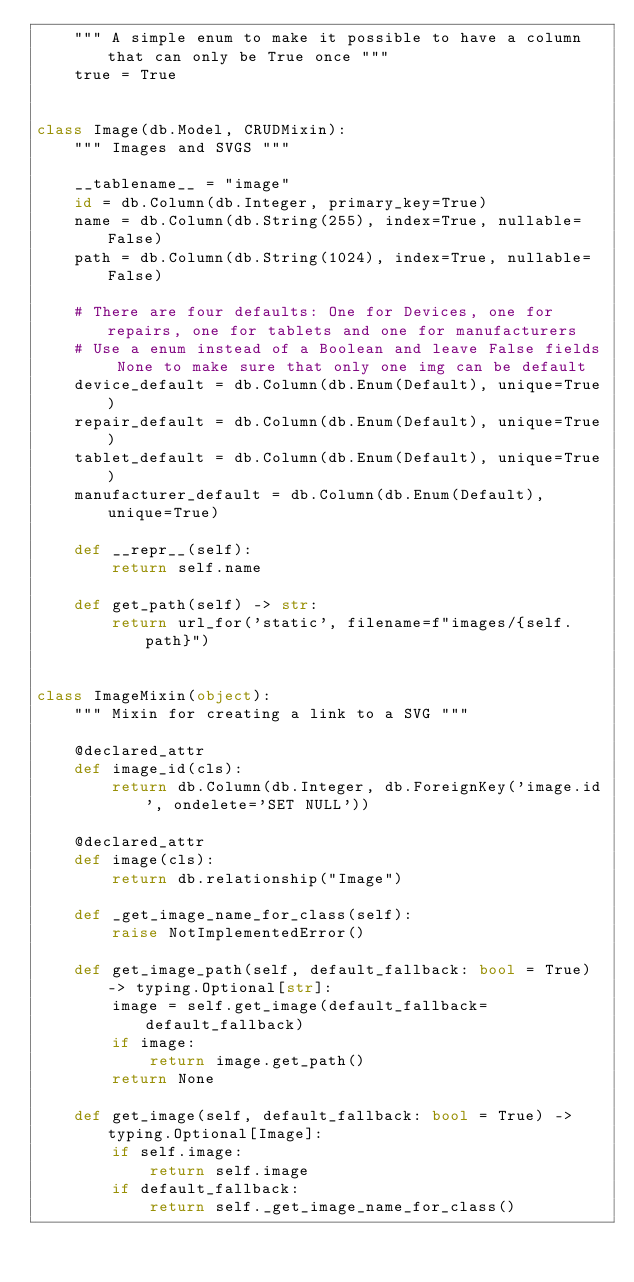Convert code to text. <code><loc_0><loc_0><loc_500><loc_500><_Python_>    """ A simple enum to make it possible to have a column that can only be True once """
    true = True


class Image(db.Model, CRUDMixin):
    """ Images and SVGS """

    __tablename__ = "image"
    id = db.Column(db.Integer, primary_key=True)
    name = db.Column(db.String(255), index=True, nullable=False)
    path = db.Column(db.String(1024), index=True, nullable=False)

    # There are four defaults: One for Devices, one for repairs, one for tablets and one for manufacturers
    # Use a enum instead of a Boolean and leave False fields None to make sure that only one img can be default
    device_default = db.Column(db.Enum(Default), unique=True)
    repair_default = db.Column(db.Enum(Default), unique=True)
    tablet_default = db.Column(db.Enum(Default), unique=True)
    manufacturer_default = db.Column(db.Enum(Default), unique=True)

    def __repr__(self):
        return self.name

    def get_path(self) -> str:
        return url_for('static', filename=f"images/{self.path}")


class ImageMixin(object):
    """ Mixin for creating a link to a SVG """

    @declared_attr
    def image_id(cls):
        return db.Column(db.Integer, db.ForeignKey('image.id', ondelete='SET NULL'))

    @declared_attr
    def image(cls):
        return db.relationship("Image")

    def _get_image_name_for_class(self):
        raise NotImplementedError()

    def get_image_path(self, default_fallback: bool = True) -> typing.Optional[str]:
        image = self.get_image(default_fallback=default_fallback)
        if image:
            return image.get_path()
        return None

    def get_image(self, default_fallback: bool = True) -> typing.Optional[Image]:
        if self.image:
            return self.image
        if default_fallback:
            return self._get_image_name_for_class()
</code> 